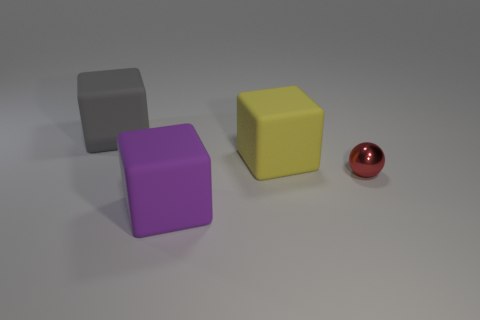Add 1 large yellow things. How many objects exist? 5 Add 2 yellow balls. How many yellow balls exist? 2 Subtract 0 cyan cylinders. How many objects are left? 4 Subtract all cubes. How many objects are left? 1 Subtract all big rubber things. Subtract all gray rubber things. How many objects are left? 0 Add 3 large blocks. How many large blocks are left? 6 